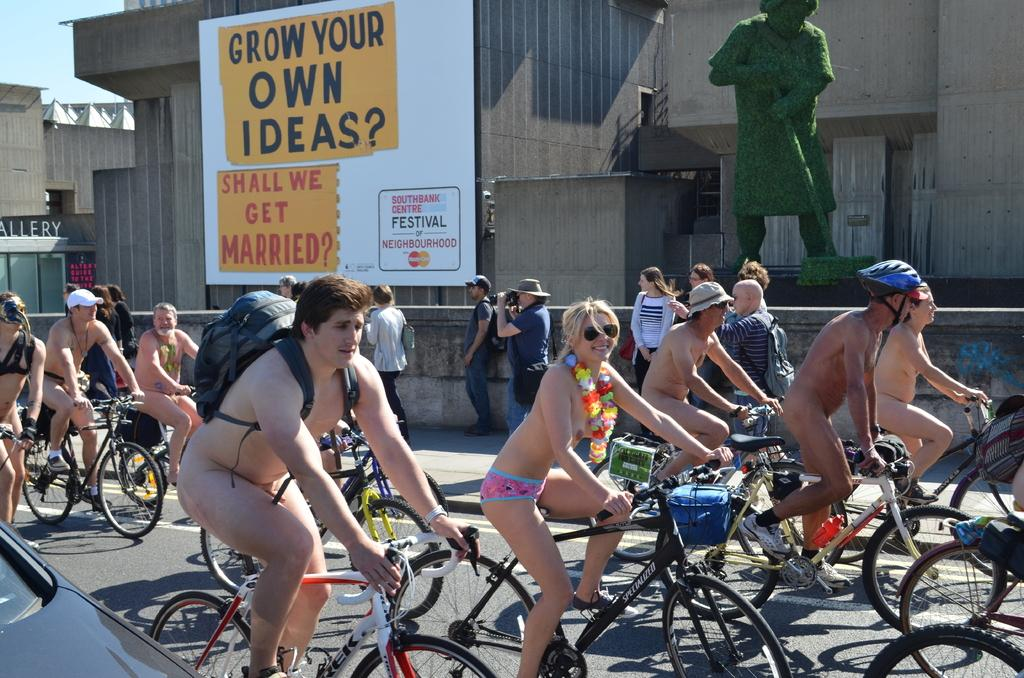What is happening in the image involving a group of people? There is a group of people in the image, and they are riding a bicycle. What can be seen in the background of the image? There is a statue and a board in the background of the image. Who is holding a camera in the image? A person is holding a camera in the image. Can you describe the man in the image with a backpack? The man wearing a backpack is in the image. What type of table is being used as an invention in the image? There is no table or invention present in the image; it features a group of people riding a bicycle, a statue and a board in the background, a person holding a camera, and a man with a backpack. 